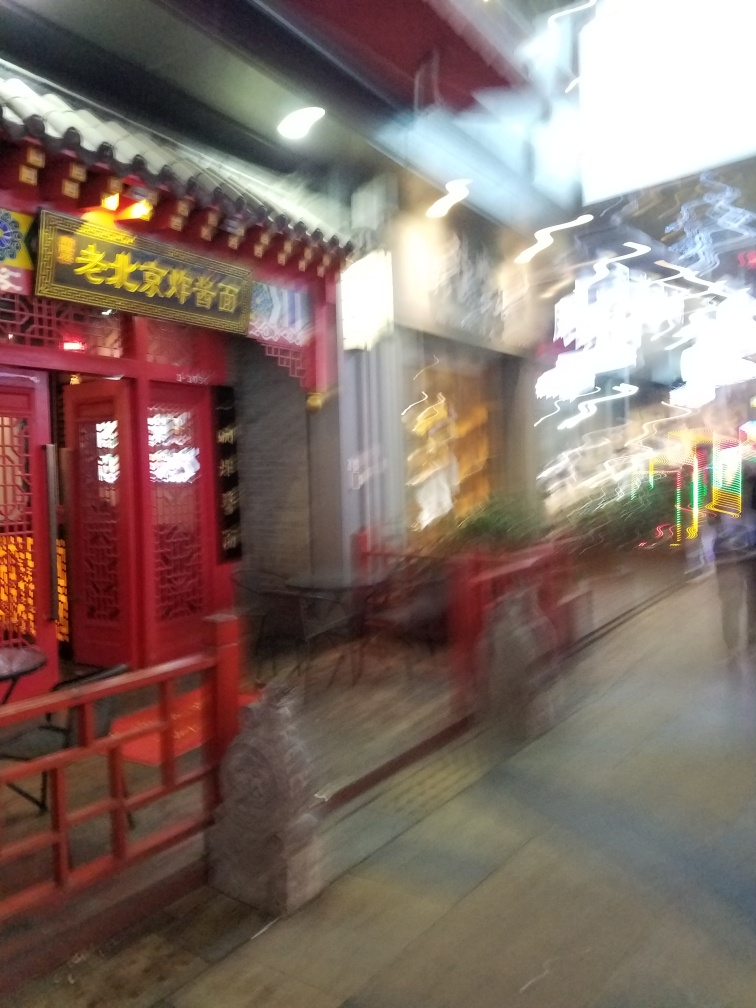Is the alley in the image a hutong alley? Based on the architectural style of the red doors and the traditional decorative elements, the alley in the image appears to be a hutong alley, which is a narrow street or alley commonly associated with northern Chinese cities, especially Beijing. These alleys are lined with traditional courtyard residences and are known for their cultural significance and communal atmosphere. 